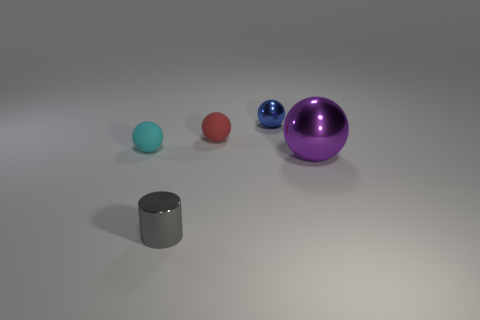The blue thing has what size?
Offer a terse response. Small. There is a rubber sphere right of the cylinder; how big is it?
Your answer should be very brief. Small. There is a shiny object that is to the left of the purple thing and in front of the tiny red matte sphere; what is its shape?
Your response must be concise. Cylinder. What number of other things are there of the same shape as the small blue object?
Offer a very short reply. 3. There is a metallic ball that is the same size as the gray metal thing; what is its color?
Give a very brief answer. Blue. How many objects are either large balls or big red cubes?
Offer a very short reply. 1. Are there any tiny cyan balls to the right of the tiny gray metal cylinder?
Offer a very short reply. No. Is there a ball made of the same material as the blue object?
Give a very brief answer. Yes. What number of spheres are either cyan rubber objects or matte objects?
Provide a succinct answer. 2. Is the number of tiny gray things that are behind the blue sphere greater than the number of red things that are to the right of the big purple ball?
Provide a succinct answer. No. 